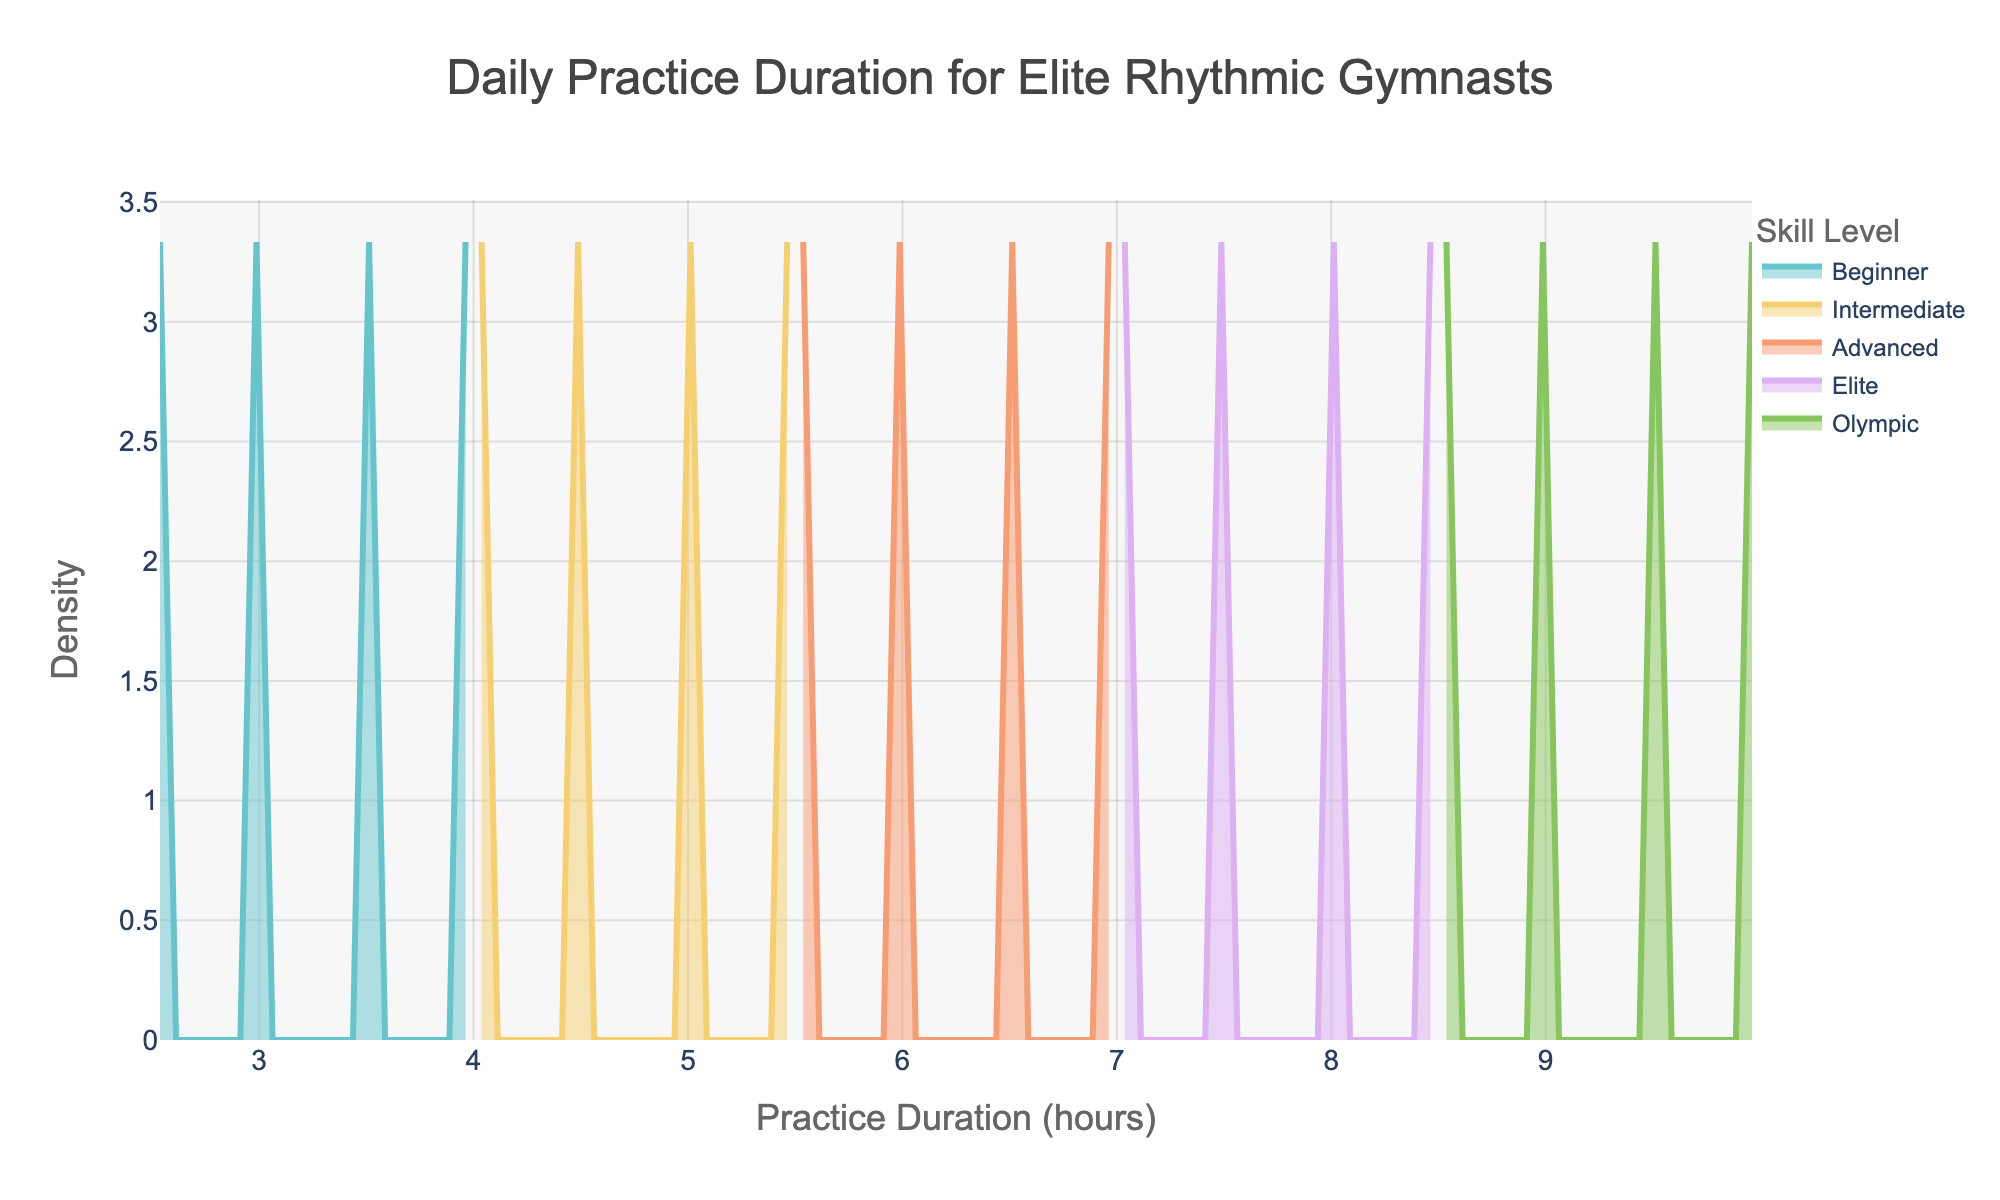What's the title of the plot? The title is usually positioned at the top center of the chart. By looking at the figure, you can see the title clearly displayed.
Answer: Daily Practice Duration for Elite Rhythmic Gymnasts Which skill level has the highest density peak? The highest density peak can be observed by looking at the highest point on the y-axis for any given line representing a skill level. The Olympic skill level has the highest peak.
Answer: Olympic How many skill levels are represented in the plot? Each distinct line on the plot represents a different skill level. By counting these lines, we can determine the number of skill levels. There are five lines, indicating five skill levels.
Answer: 5 What's the practice duration range of the Intermediate skill level? To find the practice duration range, look at the x-axis values where the density curve for Intermediate starts and ends. The range for the Intermediate level is from 4 to 5.5 hours.
Answer: 4 to 5.5 hours Which skill level has the most extended practice duration? By observing the x-axis, you can determine which skill level extends the furthest to the right. The Olympic level extends the furthest to the right up to 10 hours.
Answer: Olympic What is the average peak density of the Advanced and Elite skill levels? To find the average peak density, locate the highest point of the density curve for both Advanced and Elite. Then calculate the average by adding these peaks and dividing by two. If the Advanced peak is at 0.4 and the Elite peak is at 0.35, the average would be (0.4 + 0.35) / 2 = 0.375.
Answer: 0.375 Between Beginner and Intermediate, which has a broader range of practice durations? Compare the widths of the density curves on the x-axis for Beginner and Intermediate. The Beginner range is from 2.5 to 4, a range of 1.5 hours, and the Intermediate range is from 4 to 5.5, a range of 1.5 hours. Both have the same range.
Answer: Both have the same range At which practice duration do the Elite and Advanced densities intersect? To find the intersection, identify the point on the x-axis where the density curves of Elite and Advanced cross each other. The curves intersect around the practice duration of 7 hours.
Answer: 7 hours What's the density value for a practice duration of 6.5 hours for the Advanced skill level? Find the point on the x-axis at 6.5 hours and follow it up to the Advanced density curve. The y-value at this point is the required density value, which is approximately 0.4.
Answer: 0.4 